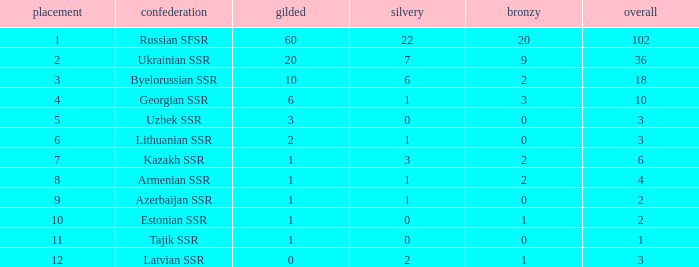What is the average total for teams with more than 1 gold, ranked over 3 and more than 3 bronze? None. 